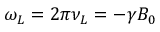<formula> <loc_0><loc_0><loc_500><loc_500>\omega _ { L } = 2 \pi \nu _ { L } = - \gamma B _ { 0 }</formula> 